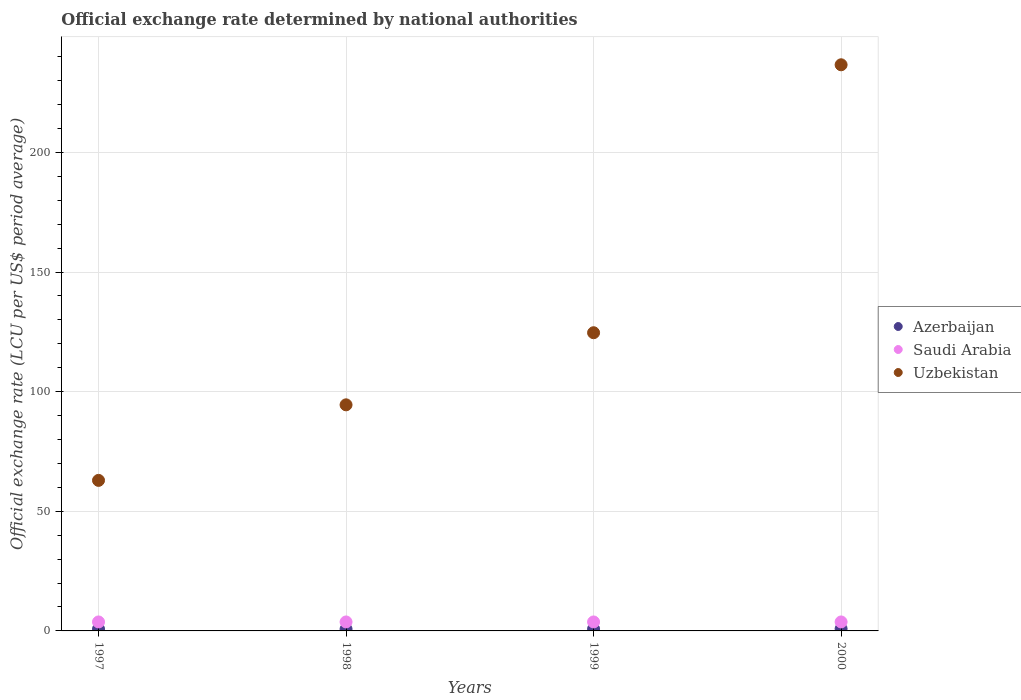How many different coloured dotlines are there?
Make the answer very short. 3. Is the number of dotlines equal to the number of legend labels?
Give a very brief answer. Yes. What is the official exchange rate in Uzbekistan in 1997?
Ensure brevity in your answer.  62.92. Across all years, what is the maximum official exchange rate in Azerbaijan?
Offer a terse response. 0.89. Across all years, what is the minimum official exchange rate in Uzbekistan?
Offer a terse response. 62.92. In which year was the official exchange rate in Azerbaijan minimum?
Offer a terse response. 1998. What is the total official exchange rate in Saudi Arabia in the graph?
Give a very brief answer. 15. What is the difference between the official exchange rate in Uzbekistan in 1997 and that in 1999?
Make the answer very short. -61.71. What is the difference between the official exchange rate in Azerbaijan in 1997 and the official exchange rate in Uzbekistan in 1999?
Give a very brief answer. -123.83. What is the average official exchange rate in Azerbaijan per year?
Provide a short and direct response. 0.82. In the year 1999, what is the difference between the official exchange rate in Uzbekistan and official exchange rate in Azerbaijan?
Your response must be concise. 123.8. What is the ratio of the official exchange rate in Uzbekistan in 1997 to that in 1999?
Keep it short and to the point. 0.5. Is the official exchange rate in Uzbekistan in 1999 less than that in 2000?
Give a very brief answer. Yes. Is the difference between the official exchange rate in Uzbekistan in 1998 and 1999 greater than the difference between the official exchange rate in Azerbaijan in 1998 and 1999?
Make the answer very short. No. What is the difference between the highest and the lowest official exchange rate in Uzbekistan?
Provide a succinct answer. 173.69. In how many years, is the official exchange rate in Azerbaijan greater than the average official exchange rate in Azerbaijan taken over all years?
Your response must be concise. 2. Is it the case that in every year, the sum of the official exchange rate in Azerbaijan and official exchange rate in Saudi Arabia  is greater than the official exchange rate in Uzbekistan?
Make the answer very short. No. Is the official exchange rate in Uzbekistan strictly greater than the official exchange rate in Azerbaijan over the years?
Offer a terse response. Yes. How many dotlines are there?
Keep it short and to the point. 3. How many years are there in the graph?
Your answer should be compact. 4. Where does the legend appear in the graph?
Your answer should be compact. Center right. How many legend labels are there?
Make the answer very short. 3. What is the title of the graph?
Give a very brief answer. Official exchange rate determined by national authorities. What is the label or title of the Y-axis?
Your answer should be very brief. Official exchange rate (LCU per US$ period average). What is the Official exchange rate (LCU per US$ period average) of Azerbaijan in 1997?
Your response must be concise. 0.8. What is the Official exchange rate (LCU per US$ period average) of Saudi Arabia in 1997?
Your response must be concise. 3.75. What is the Official exchange rate (LCU per US$ period average) of Uzbekistan in 1997?
Your answer should be compact. 62.92. What is the Official exchange rate (LCU per US$ period average) in Azerbaijan in 1998?
Ensure brevity in your answer.  0.77. What is the Official exchange rate (LCU per US$ period average) in Saudi Arabia in 1998?
Make the answer very short. 3.75. What is the Official exchange rate (LCU per US$ period average) in Uzbekistan in 1998?
Offer a terse response. 94.49. What is the Official exchange rate (LCU per US$ period average) of Azerbaijan in 1999?
Keep it short and to the point. 0.82. What is the Official exchange rate (LCU per US$ period average) of Saudi Arabia in 1999?
Make the answer very short. 3.75. What is the Official exchange rate (LCU per US$ period average) in Uzbekistan in 1999?
Provide a short and direct response. 124.62. What is the Official exchange rate (LCU per US$ period average) of Azerbaijan in 2000?
Provide a short and direct response. 0.89. What is the Official exchange rate (LCU per US$ period average) of Saudi Arabia in 2000?
Your answer should be very brief. 3.75. What is the Official exchange rate (LCU per US$ period average) of Uzbekistan in 2000?
Offer a terse response. 236.61. Across all years, what is the maximum Official exchange rate (LCU per US$ period average) in Azerbaijan?
Provide a short and direct response. 0.89. Across all years, what is the maximum Official exchange rate (LCU per US$ period average) of Saudi Arabia?
Offer a very short reply. 3.75. Across all years, what is the maximum Official exchange rate (LCU per US$ period average) in Uzbekistan?
Provide a succinct answer. 236.61. Across all years, what is the minimum Official exchange rate (LCU per US$ period average) in Azerbaijan?
Keep it short and to the point. 0.77. Across all years, what is the minimum Official exchange rate (LCU per US$ period average) of Saudi Arabia?
Make the answer very short. 3.75. Across all years, what is the minimum Official exchange rate (LCU per US$ period average) in Uzbekistan?
Your answer should be very brief. 62.92. What is the total Official exchange rate (LCU per US$ period average) in Azerbaijan in the graph?
Your answer should be very brief. 3.29. What is the total Official exchange rate (LCU per US$ period average) of Saudi Arabia in the graph?
Give a very brief answer. 15. What is the total Official exchange rate (LCU per US$ period average) of Uzbekistan in the graph?
Ensure brevity in your answer.  518.64. What is the difference between the Official exchange rate (LCU per US$ period average) in Azerbaijan in 1997 and that in 1998?
Offer a terse response. 0.02. What is the difference between the Official exchange rate (LCU per US$ period average) of Saudi Arabia in 1997 and that in 1998?
Make the answer very short. 0. What is the difference between the Official exchange rate (LCU per US$ period average) in Uzbekistan in 1997 and that in 1998?
Your answer should be compact. -31.57. What is the difference between the Official exchange rate (LCU per US$ period average) in Azerbaijan in 1997 and that in 1999?
Your answer should be compact. -0.03. What is the difference between the Official exchange rate (LCU per US$ period average) in Uzbekistan in 1997 and that in 1999?
Provide a succinct answer. -61.71. What is the difference between the Official exchange rate (LCU per US$ period average) of Azerbaijan in 1997 and that in 2000?
Offer a very short reply. -0.1. What is the difference between the Official exchange rate (LCU per US$ period average) of Saudi Arabia in 1997 and that in 2000?
Provide a succinct answer. 0. What is the difference between the Official exchange rate (LCU per US$ period average) in Uzbekistan in 1997 and that in 2000?
Your answer should be very brief. -173.69. What is the difference between the Official exchange rate (LCU per US$ period average) of Azerbaijan in 1998 and that in 1999?
Your answer should be very brief. -0.05. What is the difference between the Official exchange rate (LCU per US$ period average) of Saudi Arabia in 1998 and that in 1999?
Provide a short and direct response. 0. What is the difference between the Official exchange rate (LCU per US$ period average) in Uzbekistan in 1998 and that in 1999?
Provide a short and direct response. -30.13. What is the difference between the Official exchange rate (LCU per US$ period average) of Azerbaijan in 1998 and that in 2000?
Keep it short and to the point. -0.12. What is the difference between the Official exchange rate (LCU per US$ period average) of Uzbekistan in 1998 and that in 2000?
Keep it short and to the point. -142.12. What is the difference between the Official exchange rate (LCU per US$ period average) of Azerbaijan in 1999 and that in 2000?
Offer a terse response. -0.07. What is the difference between the Official exchange rate (LCU per US$ period average) of Saudi Arabia in 1999 and that in 2000?
Provide a succinct answer. 0. What is the difference between the Official exchange rate (LCU per US$ period average) of Uzbekistan in 1999 and that in 2000?
Your answer should be very brief. -111.98. What is the difference between the Official exchange rate (LCU per US$ period average) in Azerbaijan in 1997 and the Official exchange rate (LCU per US$ period average) in Saudi Arabia in 1998?
Your response must be concise. -2.95. What is the difference between the Official exchange rate (LCU per US$ period average) in Azerbaijan in 1997 and the Official exchange rate (LCU per US$ period average) in Uzbekistan in 1998?
Provide a short and direct response. -93.69. What is the difference between the Official exchange rate (LCU per US$ period average) in Saudi Arabia in 1997 and the Official exchange rate (LCU per US$ period average) in Uzbekistan in 1998?
Provide a short and direct response. -90.74. What is the difference between the Official exchange rate (LCU per US$ period average) of Azerbaijan in 1997 and the Official exchange rate (LCU per US$ period average) of Saudi Arabia in 1999?
Your response must be concise. -2.95. What is the difference between the Official exchange rate (LCU per US$ period average) in Azerbaijan in 1997 and the Official exchange rate (LCU per US$ period average) in Uzbekistan in 1999?
Your answer should be very brief. -123.83. What is the difference between the Official exchange rate (LCU per US$ period average) of Saudi Arabia in 1997 and the Official exchange rate (LCU per US$ period average) of Uzbekistan in 1999?
Provide a short and direct response. -120.88. What is the difference between the Official exchange rate (LCU per US$ period average) in Azerbaijan in 1997 and the Official exchange rate (LCU per US$ period average) in Saudi Arabia in 2000?
Your answer should be compact. -2.95. What is the difference between the Official exchange rate (LCU per US$ period average) of Azerbaijan in 1997 and the Official exchange rate (LCU per US$ period average) of Uzbekistan in 2000?
Offer a very short reply. -235.81. What is the difference between the Official exchange rate (LCU per US$ period average) in Saudi Arabia in 1997 and the Official exchange rate (LCU per US$ period average) in Uzbekistan in 2000?
Offer a very short reply. -232.86. What is the difference between the Official exchange rate (LCU per US$ period average) of Azerbaijan in 1998 and the Official exchange rate (LCU per US$ period average) of Saudi Arabia in 1999?
Give a very brief answer. -2.98. What is the difference between the Official exchange rate (LCU per US$ period average) in Azerbaijan in 1998 and the Official exchange rate (LCU per US$ period average) in Uzbekistan in 1999?
Offer a terse response. -123.85. What is the difference between the Official exchange rate (LCU per US$ period average) of Saudi Arabia in 1998 and the Official exchange rate (LCU per US$ period average) of Uzbekistan in 1999?
Provide a succinct answer. -120.88. What is the difference between the Official exchange rate (LCU per US$ period average) in Azerbaijan in 1998 and the Official exchange rate (LCU per US$ period average) in Saudi Arabia in 2000?
Your answer should be very brief. -2.98. What is the difference between the Official exchange rate (LCU per US$ period average) in Azerbaijan in 1998 and the Official exchange rate (LCU per US$ period average) in Uzbekistan in 2000?
Ensure brevity in your answer.  -235.83. What is the difference between the Official exchange rate (LCU per US$ period average) in Saudi Arabia in 1998 and the Official exchange rate (LCU per US$ period average) in Uzbekistan in 2000?
Keep it short and to the point. -232.86. What is the difference between the Official exchange rate (LCU per US$ period average) in Azerbaijan in 1999 and the Official exchange rate (LCU per US$ period average) in Saudi Arabia in 2000?
Provide a short and direct response. -2.93. What is the difference between the Official exchange rate (LCU per US$ period average) in Azerbaijan in 1999 and the Official exchange rate (LCU per US$ period average) in Uzbekistan in 2000?
Provide a succinct answer. -235.78. What is the difference between the Official exchange rate (LCU per US$ period average) in Saudi Arabia in 1999 and the Official exchange rate (LCU per US$ period average) in Uzbekistan in 2000?
Your answer should be compact. -232.86. What is the average Official exchange rate (LCU per US$ period average) of Azerbaijan per year?
Ensure brevity in your answer.  0.82. What is the average Official exchange rate (LCU per US$ period average) of Saudi Arabia per year?
Your answer should be very brief. 3.75. What is the average Official exchange rate (LCU per US$ period average) in Uzbekistan per year?
Make the answer very short. 129.66. In the year 1997, what is the difference between the Official exchange rate (LCU per US$ period average) of Azerbaijan and Official exchange rate (LCU per US$ period average) of Saudi Arabia?
Ensure brevity in your answer.  -2.95. In the year 1997, what is the difference between the Official exchange rate (LCU per US$ period average) of Azerbaijan and Official exchange rate (LCU per US$ period average) of Uzbekistan?
Keep it short and to the point. -62.12. In the year 1997, what is the difference between the Official exchange rate (LCU per US$ period average) of Saudi Arabia and Official exchange rate (LCU per US$ period average) of Uzbekistan?
Make the answer very short. -59.17. In the year 1998, what is the difference between the Official exchange rate (LCU per US$ period average) of Azerbaijan and Official exchange rate (LCU per US$ period average) of Saudi Arabia?
Ensure brevity in your answer.  -2.98. In the year 1998, what is the difference between the Official exchange rate (LCU per US$ period average) of Azerbaijan and Official exchange rate (LCU per US$ period average) of Uzbekistan?
Your response must be concise. -93.72. In the year 1998, what is the difference between the Official exchange rate (LCU per US$ period average) of Saudi Arabia and Official exchange rate (LCU per US$ period average) of Uzbekistan?
Offer a very short reply. -90.74. In the year 1999, what is the difference between the Official exchange rate (LCU per US$ period average) in Azerbaijan and Official exchange rate (LCU per US$ period average) in Saudi Arabia?
Keep it short and to the point. -2.93. In the year 1999, what is the difference between the Official exchange rate (LCU per US$ period average) of Azerbaijan and Official exchange rate (LCU per US$ period average) of Uzbekistan?
Provide a short and direct response. -123.8. In the year 1999, what is the difference between the Official exchange rate (LCU per US$ period average) in Saudi Arabia and Official exchange rate (LCU per US$ period average) in Uzbekistan?
Your answer should be compact. -120.88. In the year 2000, what is the difference between the Official exchange rate (LCU per US$ period average) in Azerbaijan and Official exchange rate (LCU per US$ period average) in Saudi Arabia?
Your response must be concise. -2.86. In the year 2000, what is the difference between the Official exchange rate (LCU per US$ period average) of Azerbaijan and Official exchange rate (LCU per US$ period average) of Uzbekistan?
Give a very brief answer. -235.71. In the year 2000, what is the difference between the Official exchange rate (LCU per US$ period average) in Saudi Arabia and Official exchange rate (LCU per US$ period average) in Uzbekistan?
Your answer should be very brief. -232.86. What is the ratio of the Official exchange rate (LCU per US$ period average) of Azerbaijan in 1997 to that in 1998?
Offer a terse response. 1.03. What is the ratio of the Official exchange rate (LCU per US$ period average) of Saudi Arabia in 1997 to that in 1998?
Provide a succinct answer. 1. What is the ratio of the Official exchange rate (LCU per US$ period average) of Uzbekistan in 1997 to that in 1998?
Your answer should be compact. 0.67. What is the ratio of the Official exchange rate (LCU per US$ period average) in Azerbaijan in 1997 to that in 1999?
Make the answer very short. 0.97. What is the ratio of the Official exchange rate (LCU per US$ period average) of Saudi Arabia in 1997 to that in 1999?
Make the answer very short. 1. What is the ratio of the Official exchange rate (LCU per US$ period average) in Uzbekistan in 1997 to that in 1999?
Your answer should be very brief. 0.5. What is the ratio of the Official exchange rate (LCU per US$ period average) in Azerbaijan in 1997 to that in 2000?
Your answer should be compact. 0.89. What is the ratio of the Official exchange rate (LCU per US$ period average) of Saudi Arabia in 1997 to that in 2000?
Keep it short and to the point. 1. What is the ratio of the Official exchange rate (LCU per US$ period average) in Uzbekistan in 1997 to that in 2000?
Provide a short and direct response. 0.27. What is the ratio of the Official exchange rate (LCU per US$ period average) of Azerbaijan in 1998 to that in 1999?
Provide a succinct answer. 0.94. What is the ratio of the Official exchange rate (LCU per US$ period average) in Saudi Arabia in 1998 to that in 1999?
Ensure brevity in your answer.  1. What is the ratio of the Official exchange rate (LCU per US$ period average) in Uzbekistan in 1998 to that in 1999?
Offer a very short reply. 0.76. What is the ratio of the Official exchange rate (LCU per US$ period average) in Azerbaijan in 1998 to that in 2000?
Offer a terse response. 0.86. What is the ratio of the Official exchange rate (LCU per US$ period average) of Saudi Arabia in 1998 to that in 2000?
Your answer should be compact. 1. What is the ratio of the Official exchange rate (LCU per US$ period average) of Uzbekistan in 1998 to that in 2000?
Offer a terse response. 0.4. What is the ratio of the Official exchange rate (LCU per US$ period average) in Azerbaijan in 1999 to that in 2000?
Offer a very short reply. 0.92. What is the ratio of the Official exchange rate (LCU per US$ period average) of Uzbekistan in 1999 to that in 2000?
Your answer should be very brief. 0.53. What is the difference between the highest and the second highest Official exchange rate (LCU per US$ period average) in Azerbaijan?
Your answer should be very brief. 0.07. What is the difference between the highest and the second highest Official exchange rate (LCU per US$ period average) in Saudi Arabia?
Ensure brevity in your answer.  0. What is the difference between the highest and the second highest Official exchange rate (LCU per US$ period average) of Uzbekistan?
Give a very brief answer. 111.98. What is the difference between the highest and the lowest Official exchange rate (LCU per US$ period average) of Azerbaijan?
Give a very brief answer. 0.12. What is the difference between the highest and the lowest Official exchange rate (LCU per US$ period average) in Uzbekistan?
Provide a succinct answer. 173.69. 